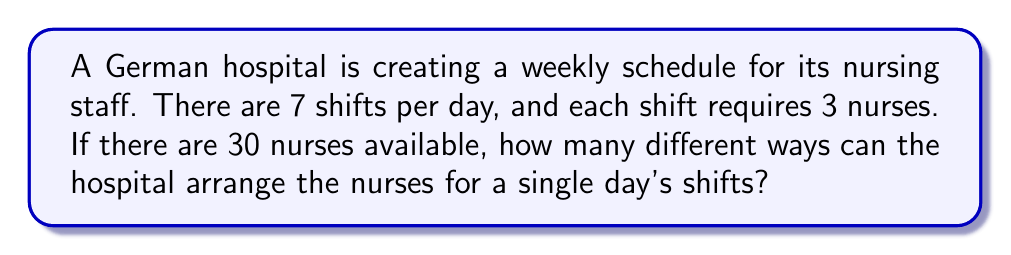What is the answer to this math problem? Let's approach this step-by-step:

1. We need to select 21 nurses (3 nurses for each of the 7 shifts) out of 30 available nurses.

2. This is a combination problem, as the order within each shift doesn't matter, but the selection of nurses for each shift does.

3. We can use the combination formula:

   $${n \choose k} = \frac{n!}{k!(n-k)!}$$

   Where $n$ is the total number of nurses (30) and $k$ is the number of nurses needed per day (21).

4. Plugging in the numbers:

   $$\frac{30!}{21!(30-21)!} = \frac{30!}{21!9!}$$

5. This gives us the number of ways to select 21 nurses out of 30.

6. However, we need to arrange these 21 nurses into 7 shifts of 3 nurses each.

7. This is a partition problem. We can use the multinomial coefficient:

   $$\frac{21!}{(3!)^7}$$

8. Combining steps 4 and 7, our final calculation is:

   $$\frac{30!}{21!9!} \cdot \frac{21!}{(3!)^7}$$

9. Simplifying:

   $$\frac{30!}{9!(3!)^7}$$

This represents the total number of ways to arrange 30 nurses into 7 shifts of 3 nurses each for a single day.
Answer: $$\frac{30!}{9!(3!)^7}$$ unique arrangements 